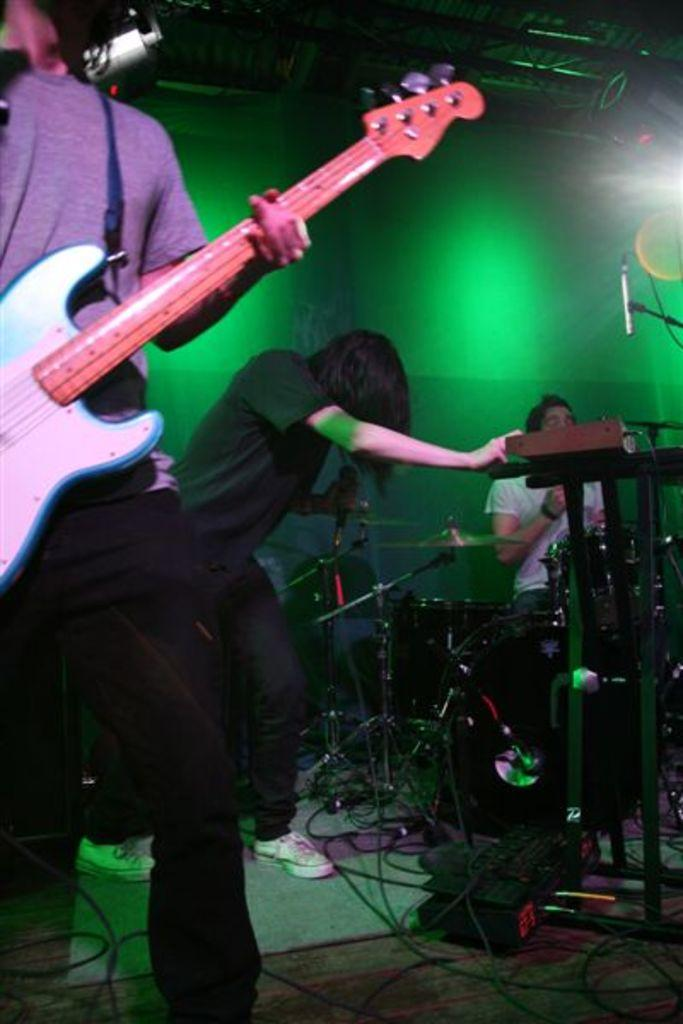How many men are present in the image? There are three men present in the image. What are the men doing in the image? One man is standing, one man is playing a drum set, and one man is playing a guitar. What color is the light in the image? The light in the image is green. What type of board is the man standing on in the image? There is no board present in the image; the man is standing on the ground. What is the father's role in the image? There is no father mentioned or depicted in the image. 